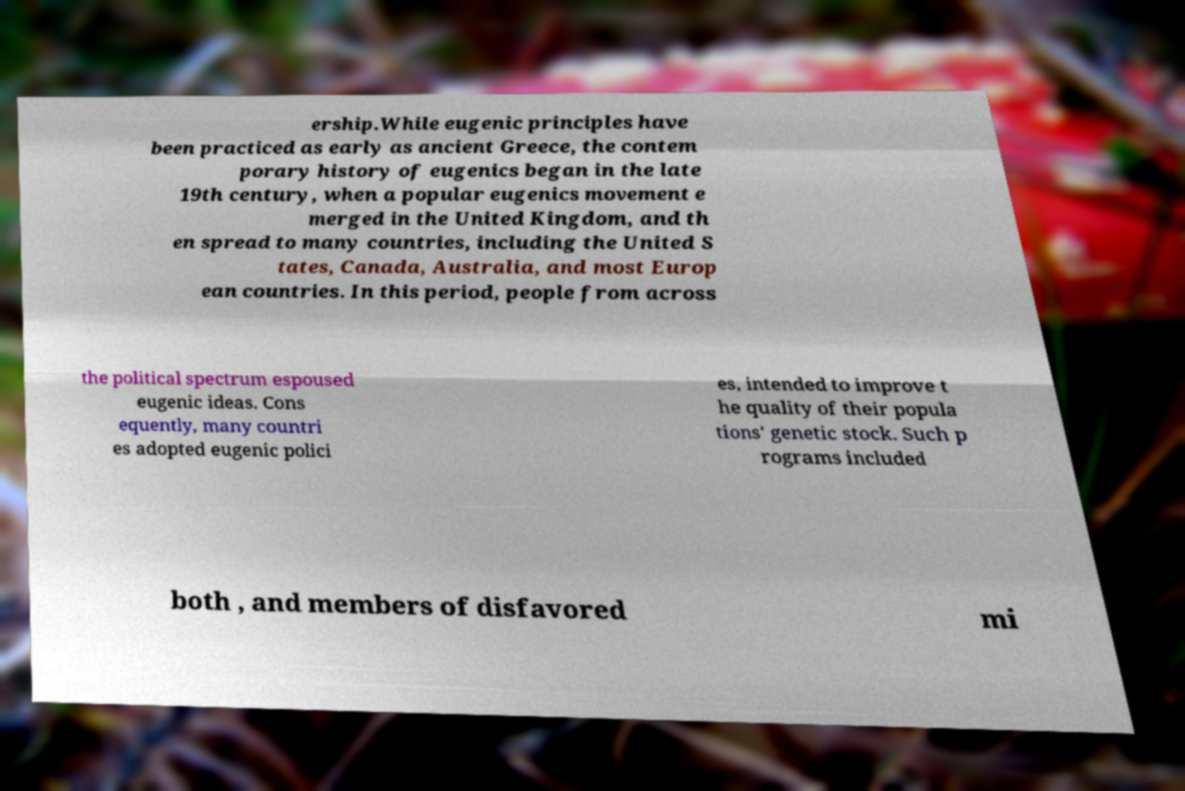What messages or text are displayed in this image? I need them in a readable, typed format. ership.While eugenic principles have been practiced as early as ancient Greece, the contem porary history of eugenics began in the late 19th century, when a popular eugenics movement e merged in the United Kingdom, and th en spread to many countries, including the United S tates, Canada, Australia, and most Europ ean countries. In this period, people from across the political spectrum espoused eugenic ideas. Cons equently, many countri es adopted eugenic polici es, intended to improve t he quality of their popula tions' genetic stock. Such p rograms included both , and members of disfavored mi 